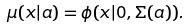<formula> <loc_0><loc_0><loc_500><loc_500>\mu ( x | a ) = \phi ( x | 0 , \Sigma ( a ) ) .</formula> 